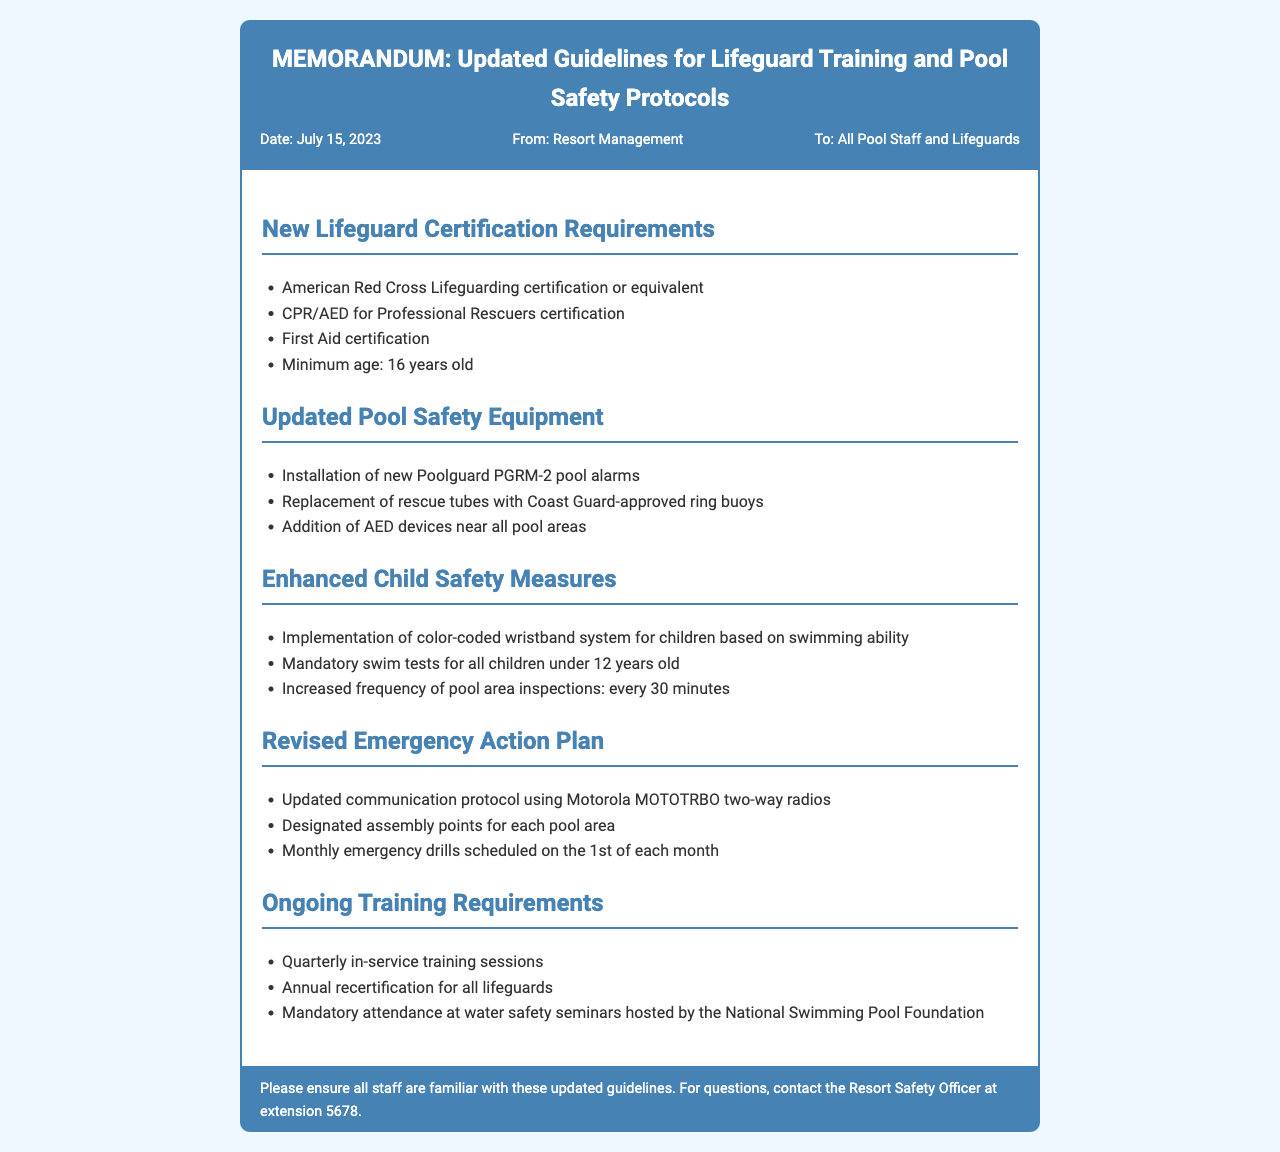What are the new lifeguard certification requirements? The document lists specific certifications required for lifeguards, including American Red Cross Lifeguarding certification or equivalent and CPR/AED for Professional Rescuers certification.
Answer: American Red Cross Lifeguarding certification or equivalent, CPR/AED for Professional Rescuers certification, First Aid certification What is the minimum age for lifeguards? The fax specifies the minimum age requirement for lifeguards.
Answer: 16 years old What safety equipment is newly updated? The document identifies the updated safety equipment, including installation of new pool alarms and replacement of rescue tubes.
Answer: Poolguard PGRM-2 pool alarms, Coast Guard-approved ring buoys, AED devices How frequently will pool area inspections be conducted? The document states increased frequency of inspections for child safety measures.
Answer: every 30 minutes What is the date of the memorandum? The document provides the date on which the guidelines were issued.
Answer: July 15, 2023 What system is implemented for children's swimming ability? The fax introduces a system for ensuring child safety based on swimming skills.
Answer: Color-coded wristband system How often are monthly emergency drills scheduled? The document specifies the recurrence of scheduled emergency drills.
Answer: 1st of each month What will happen if a lifeguard fails to attend the training sessions? While the document does not specify consequences directly, it implies ongoing training is mandatory for responsibilities.
Answer: Mandatory attendance What communication protocol is updated in the emergency action plan? The document mentions a specific protocol for emergency communication.
Answer: Motorola MOTOTRBO two-way radios 